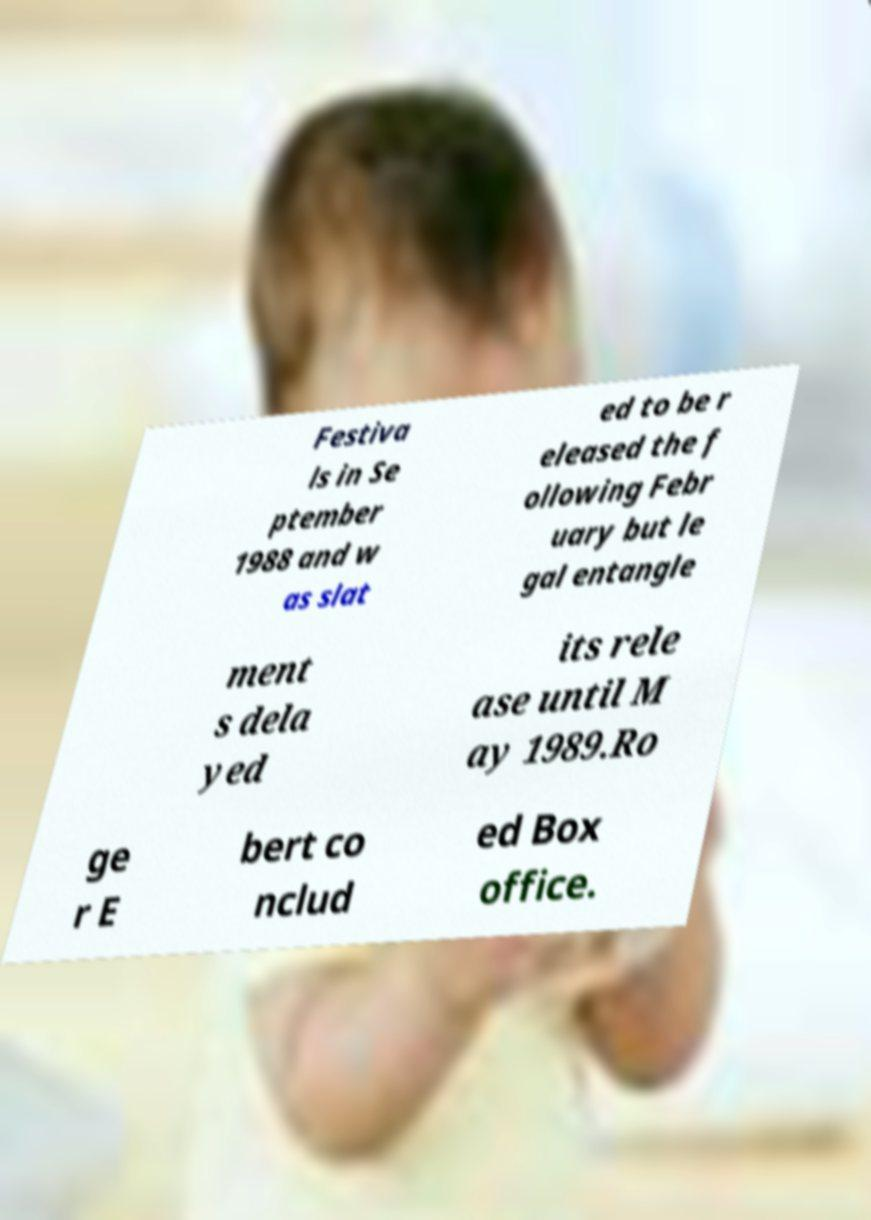For documentation purposes, I need the text within this image transcribed. Could you provide that? Festiva ls in Se ptember 1988 and w as slat ed to be r eleased the f ollowing Febr uary but le gal entangle ment s dela yed its rele ase until M ay 1989.Ro ge r E bert co nclud ed Box office. 